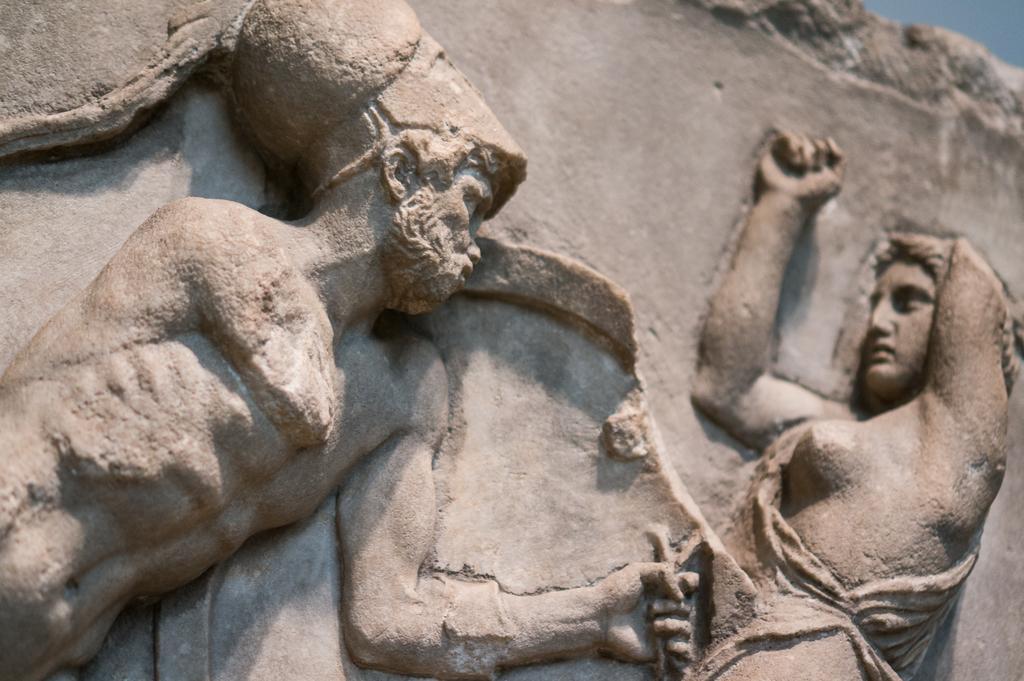In one or two sentences, can you explain what this image depicts? In the image we can see some sculptures. 